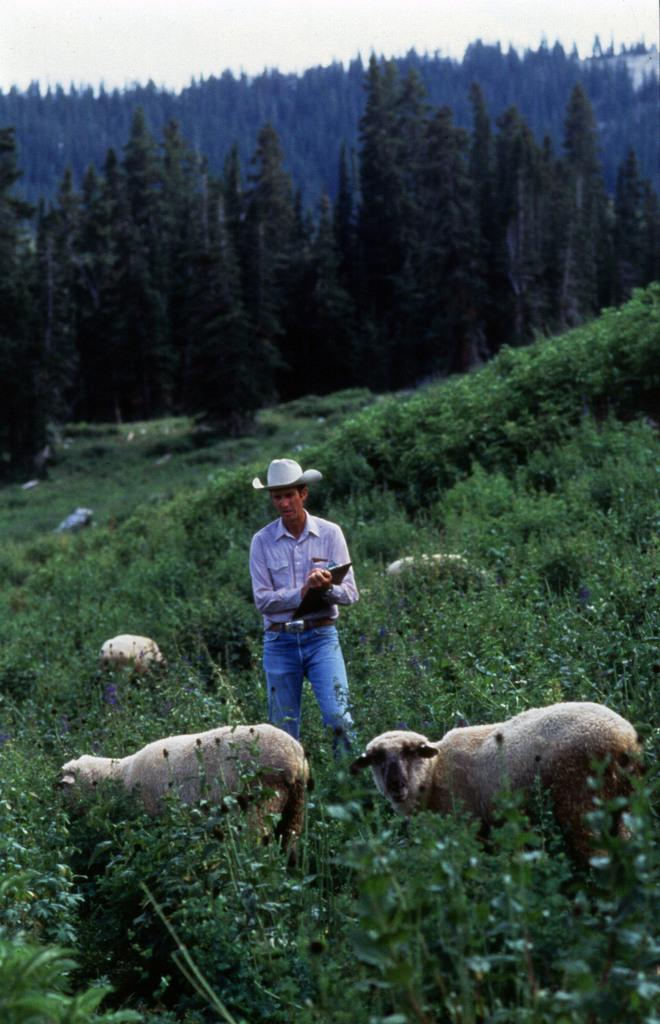What is the man in the image doing? The man is standing in the image and holding a pad. What else can be seen in the image besides the man? There is a group of herd, plants, a group of trees, and the sky visible in the image. How would you describe the sky in the image? The sky appears cloudy in the image. What type of veil is draped over the herd in the image? There is no veil present in the image; it features a group of herd, plants, trees, and a man holding a pad. Is there a bomb visible in the image? No, there is no bomb present in the image. 